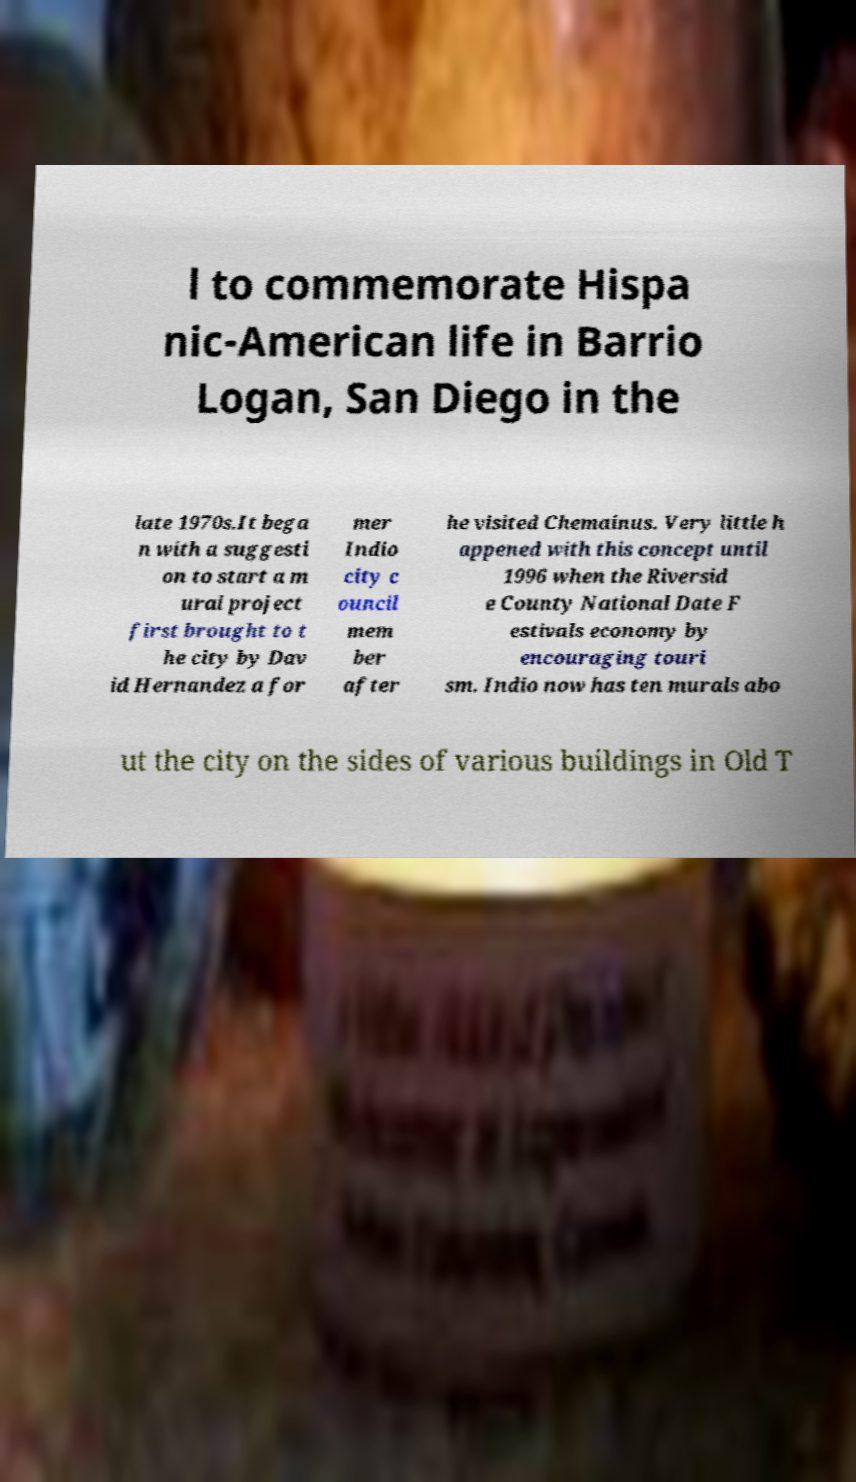Could you extract and type out the text from this image? l to commemorate Hispa nic-American life in Barrio Logan, San Diego in the late 1970s.It bega n with a suggesti on to start a m ural project first brought to t he city by Dav id Hernandez a for mer Indio city c ouncil mem ber after he visited Chemainus. Very little h appened with this concept until 1996 when the Riversid e County National Date F estivals economy by encouraging touri sm. Indio now has ten murals abo ut the city on the sides of various buildings in Old T 